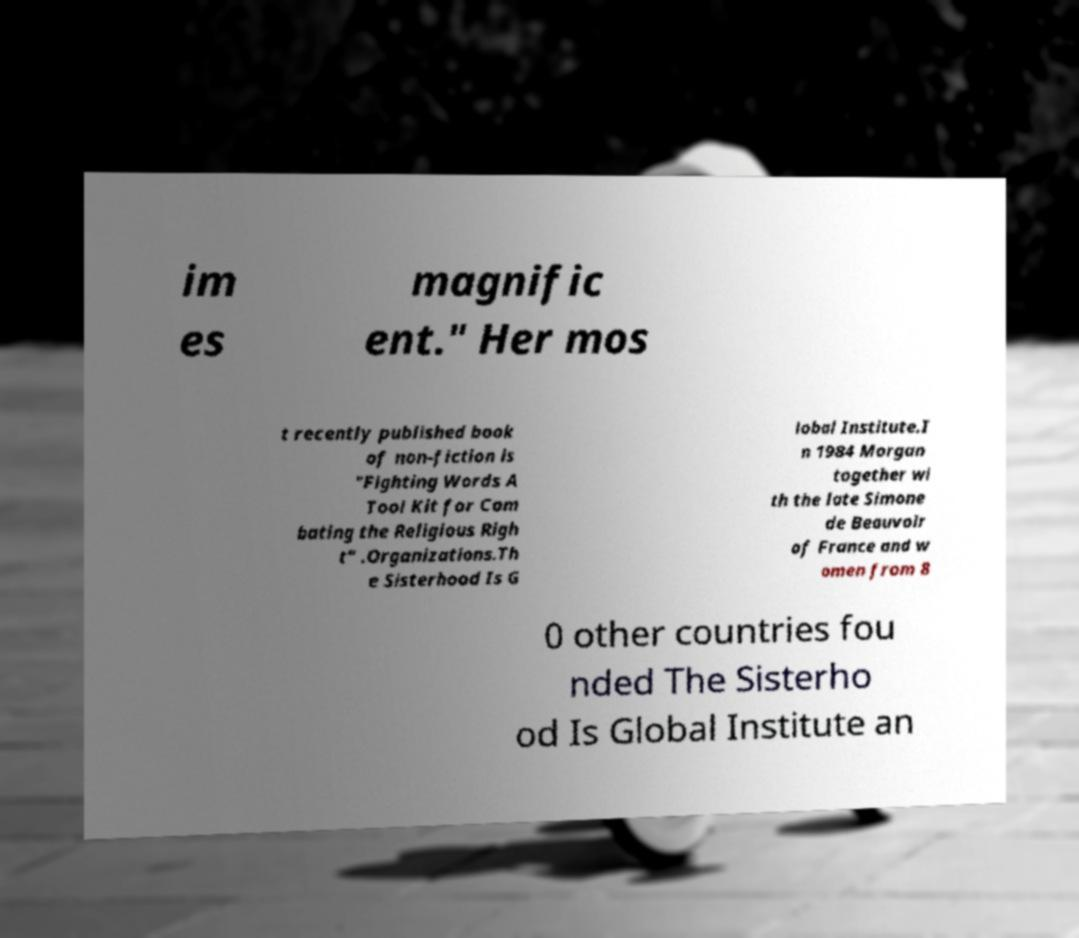For documentation purposes, I need the text within this image transcribed. Could you provide that? im es magnific ent." Her mos t recently published book of non-fiction is "Fighting Words A Tool Kit for Com bating the Religious Righ t" .Organizations.Th e Sisterhood Is G lobal Institute.I n 1984 Morgan together wi th the late Simone de Beauvoir of France and w omen from 8 0 other countries fou nded The Sisterho od Is Global Institute an 